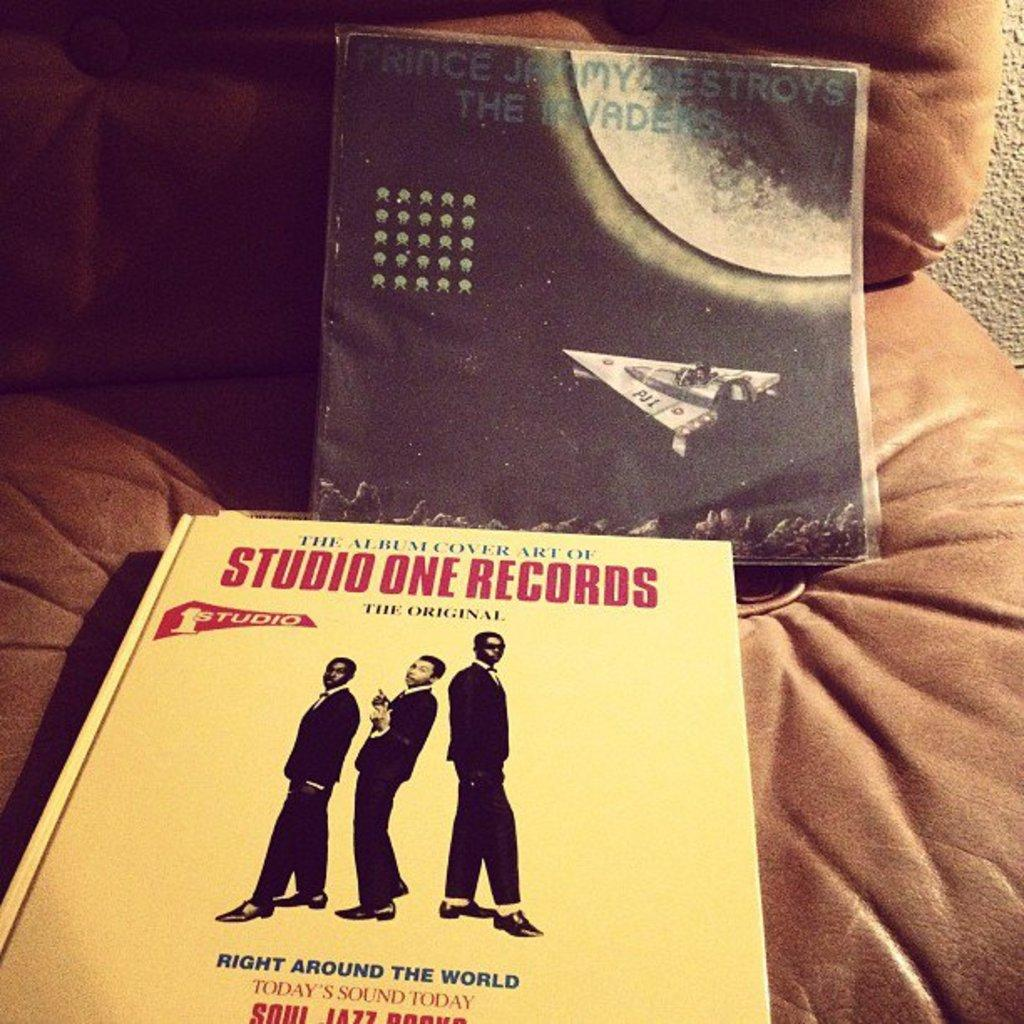<image>
Give a short and clear explanation of the subsequent image. The album cover states it's put out by Studio One Records and it's "Today's sound today". 